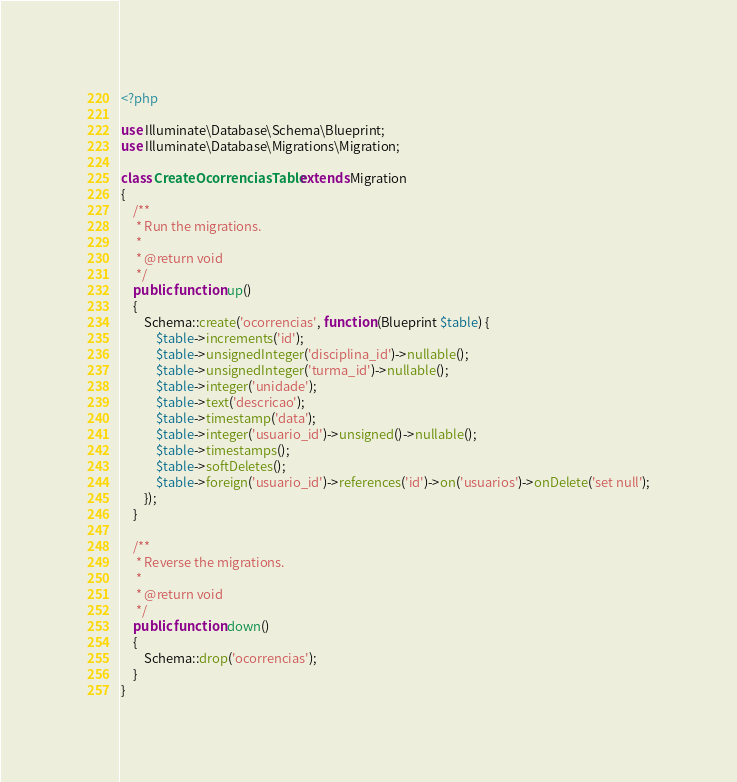<code> <loc_0><loc_0><loc_500><loc_500><_PHP_><?php

use Illuminate\Database\Schema\Blueprint;
use Illuminate\Database\Migrations\Migration;

class CreateOcorrenciasTable extends Migration
{
    /**
     * Run the migrations.
     *
     * @return void
     */
    public function up()
    {
        Schema::create('ocorrencias', function (Blueprint $table) {
            $table->increments('id');
            $table->unsignedInteger('disciplina_id')->nullable();
            $table->unsignedInteger('turma_id')->nullable();
            $table->integer('unidade');
            $table->text('descricao');
            $table->timestamp('data');
            $table->integer('usuario_id')->unsigned()->nullable();
            $table->timestamps();
            $table->softDeletes();
            $table->foreign('usuario_id')->references('id')->on('usuarios')->onDelete('set null');
        });
    }

    /**
     * Reverse the migrations.
     *
     * @return void
     */
    public function down()
    {
        Schema::drop('ocorrencias');
    }
}
</code> 